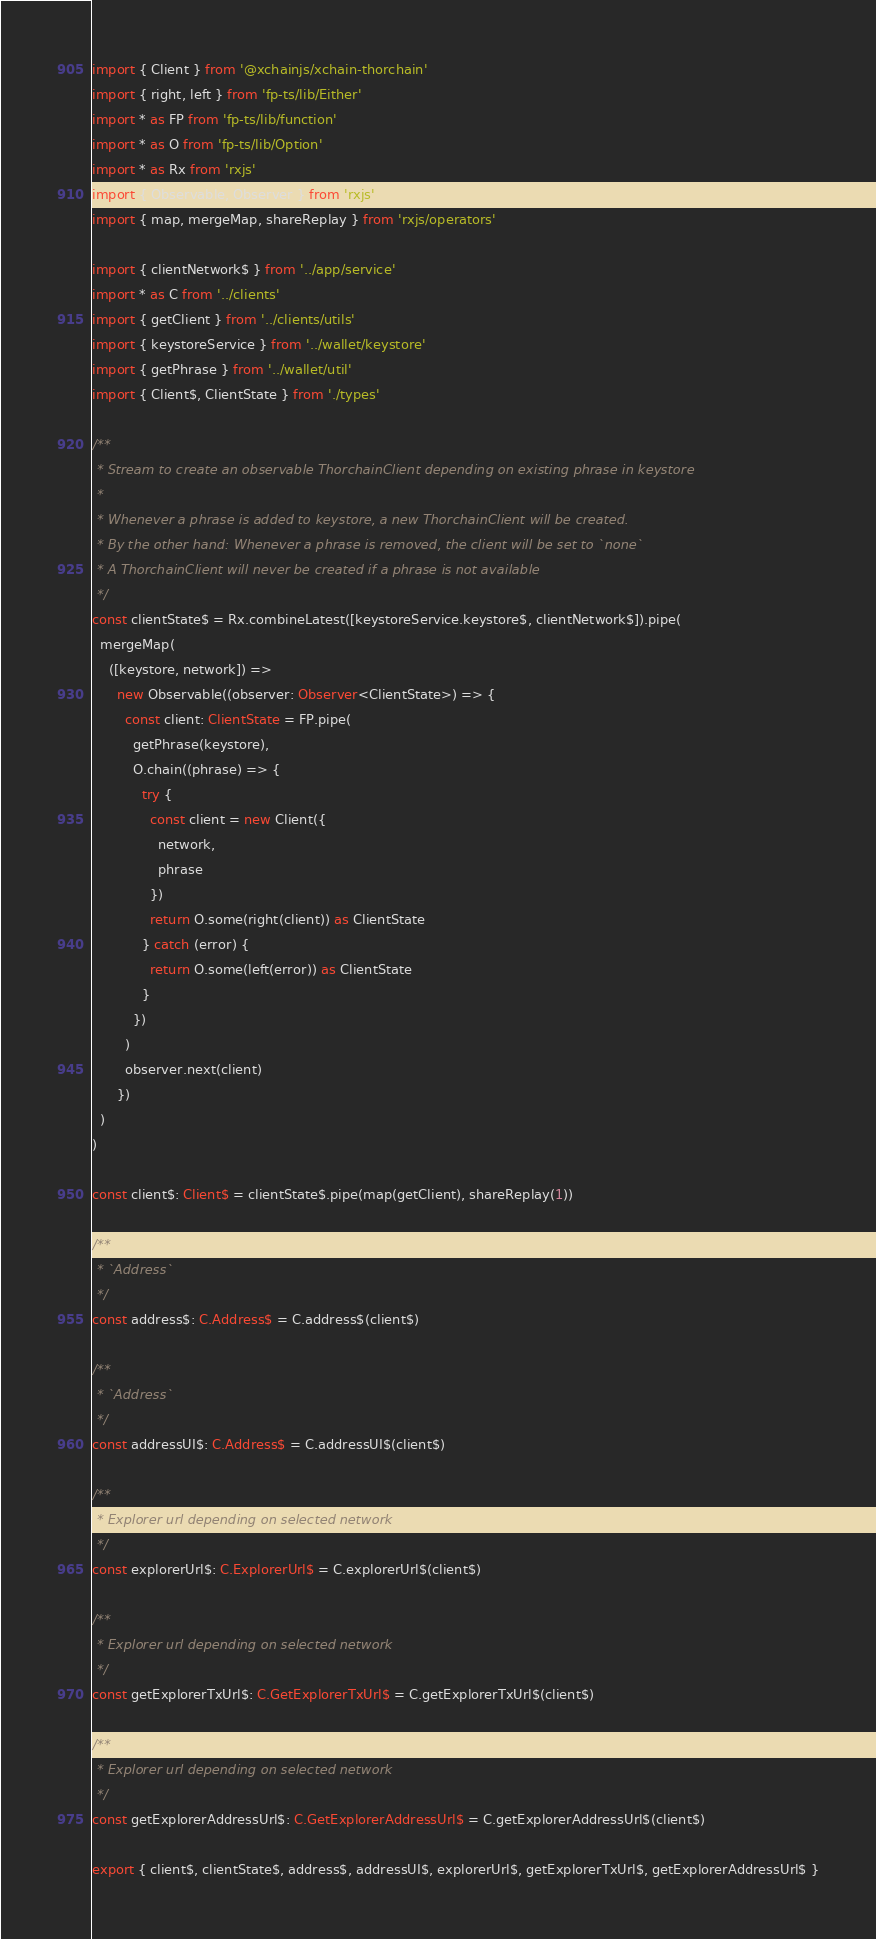<code> <loc_0><loc_0><loc_500><loc_500><_TypeScript_>import { Client } from '@xchainjs/xchain-thorchain'
import { right, left } from 'fp-ts/lib/Either'
import * as FP from 'fp-ts/lib/function'
import * as O from 'fp-ts/lib/Option'
import * as Rx from 'rxjs'
import { Observable, Observer } from 'rxjs'
import { map, mergeMap, shareReplay } from 'rxjs/operators'

import { clientNetwork$ } from '../app/service'
import * as C from '../clients'
import { getClient } from '../clients/utils'
import { keystoreService } from '../wallet/keystore'
import { getPhrase } from '../wallet/util'
import { Client$, ClientState } from './types'

/**
 * Stream to create an observable ThorchainClient depending on existing phrase in keystore
 *
 * Whenever a phrase is added to keystore, a new ThorchainClient will be created.
 * By the other hand: Whenever a phrase is removed, the client will be set to `none`
 * A ThorchainClient will never be created if a phrase is not available
 */
const clientState$ = Rx.combineLatest([keystoreService.keystore$, clientNetwork$]).pipe(
  mergeMap(
    ([keystore, network]) =>
      new Observable((observer: Observer<ClientState>) => {
        const client: ClientState = FP.pipe(
          getPhrase(keystore),
          O.chain((phrase) => {
            try {
              const client = new Client({
                network,
                phrase
              })
              return O.some(right(client)) as ClientState
            } catch (error) {
              return O.some(left(error)) as ClientState
            }
          })
        )
        observer.next(client)
      })
  )
)

const client$: Client$ = clientState$.pipe(map(getClient), shareReplay(1))

/**
 * `Address`
 */
const address$: C.Address$ = C.address$(client$)

/**
 * `Address`
 */
const addressUI$: C.Address$ = C.addressUI$(client$)

/**
 * Explorer url depending on selected network
 */
const explorerUrl$: C.ExplorerUrl$ = C.explorerUrl$(client$)

/**
 * Explorer url depending on selected network
 */
const getExplorerTxUrl$: C.GetExplorerTxUrl$ = C.getExplorerTxUrl$(client$)

/**
 * Explorer url depending on selected network
 */
const getExplorerAddressUrl$: C.GetExplorerAddressUrl$ = C.getExplorerAddressUrl$(client$)

export { client$, clientState$, address$, addressUI$, explorerUrl$, getExplorerTxUrl$, getExplorerAddressUrl$ }
</code> 